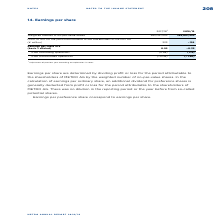According to Metro Ag's financial document, How are earnings per share determined? by dividing profit or loss for the period attributable to the shareholders of METRO AG by the weighted number of no-par-value shares. The document states: "Earnings per share are determined by dividing profit or loss for the period attributable to the shareholders of METRO AG by the weighted number of no-..." Also, What do Earnings per preference share correspond to? According to the financial document, earnings per share.. The relevant text states: "Earnings per preference share correspond to earnings per share...." Also, From what operations is the earnings per share calculated for? The document shows two values: from continuing operations and from discontinued operations. From the document: "from discontinued operations (−0.06) (−1.46) from continuing operations (0.98) (1.12)..." Additionally, In which year was the absolute value of the Earnings per share larger? Based on the financial document, the answer is 2017/2018. Also, can you calculate: What was the change in the Weighted number of no-par-value shares in 2018/2019 from 2017/2018? I cannot find a specific answer to this question in the financial document. Also, can you calculate: What was the percentage change in the Weighted number of no-par-value shares in 2018/2019 from 2017/2018? I cannot find a specific answer to this question in the financial document. 